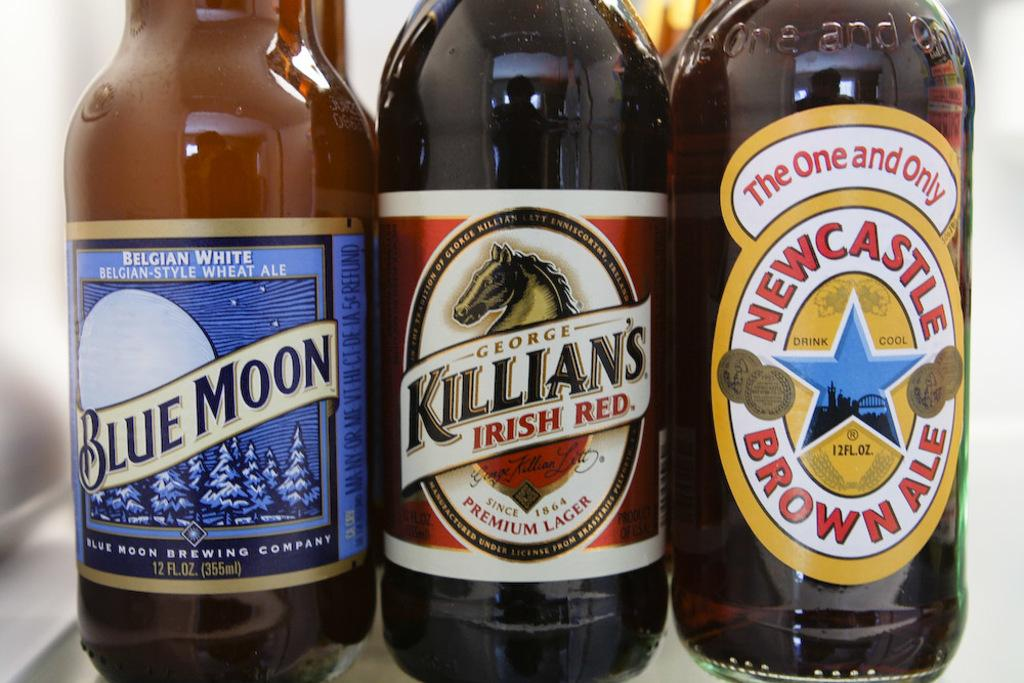<image>
Write a terse but informative summary of the picture. 3 glasses of beer such as Blue Moon 